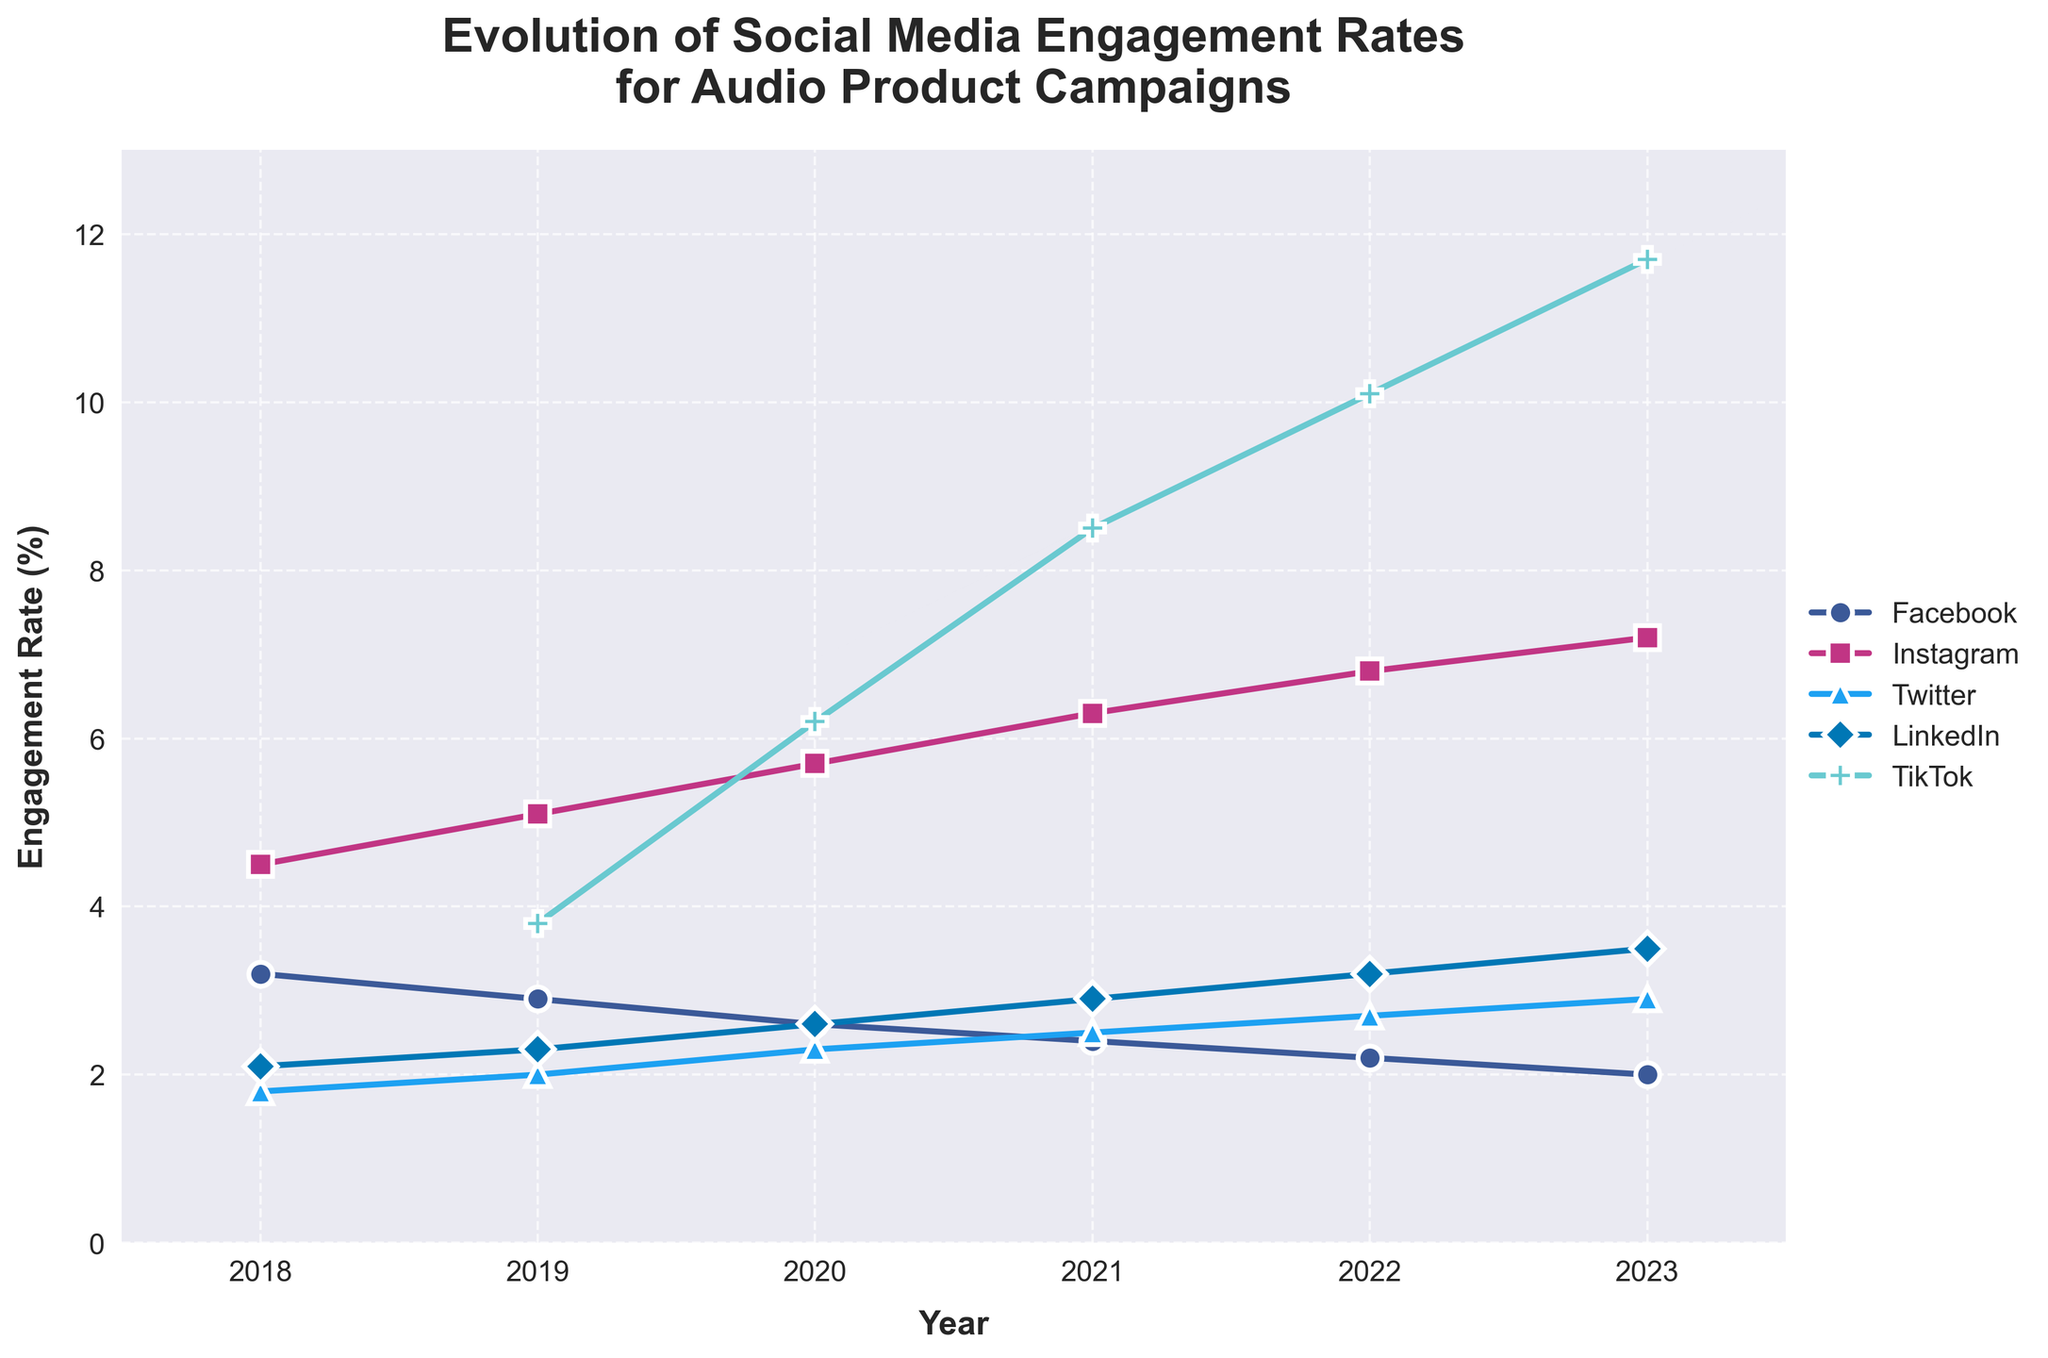What year did TikTok first appear in the engagement rate data? The figure shows the presence of TikTok engagement rates starting from a specific year. By checking the TikTok line, we can see it starts from 2019.
Answer: 2019 Which platform had the highest engagement rate in 2023? The figure shows different lines representing the platforms, and in 2023, the highest line corresponds to TikTok.
Answer: TikTok How did the engagement rate for Facebook change from 2018 to 2023? We look at the Facebook line from 2018 to 2023 and observe the trend. The engagement rate decreased from 3.2% to 2.0%.
Answer: Decreased Which two platforms had engagement rates closest to each other in 2019? Comparing the lines for different platforms in 2019, we see that Facebook (2.9%) and LinkedIn (2.3%) have the closest engagement rates.
Answer: Facebook and LinkedIn What is the average engagement rate for Instagram from 2019 to 2023? We sum the Instagram engagement rates for 2019 to 2023 and divide by the number of years: (5.1% + 5.7% + 6.3% + 6.8% + 7.2%) / 5 = 6.22%.
Answer: 6.22% Which platform shows the most consistent increase in engagement rates over the years? By visually inspecting the slope of the lines from 2018 to 2023, TikTok shows a consistent increase each year.
Answer: TikTok What is the difference in engagement rate between Instagram and Twitter in 2021? We find the engagement rates for Instagram and Twitter in 2021: Instagram (6.3%) and Twitter (2.5%), then subtract the two: 6.3% - 2.5% = 3.8%.
Answer: 3.8% How did the engagement rate for LinkedIn change from 2020 to 2022? Checking the LinkedIn line from 2020 to 2022, the engagement rate increased from 2.6% to 3.2%.
Answer: Increased Which platform had the smallest increase in engagement rate from 2018 to 2023? By visually comparing the total increase for each line, Facebook shows the smallest increase, declining overall.
Answer: Facebook Comparing TikTok and Instagram, which platform had a higher engagement growth rate from 2019 to 2022? We find the initial and final engagement rates for TikTok (3.8% to 10.1%) and Instagram (5.1% to 6.8%), calculate the difference: TikTok (6.3%) and Instagram (1.7%). TikTok had higher growth.
Answer: TikTok 